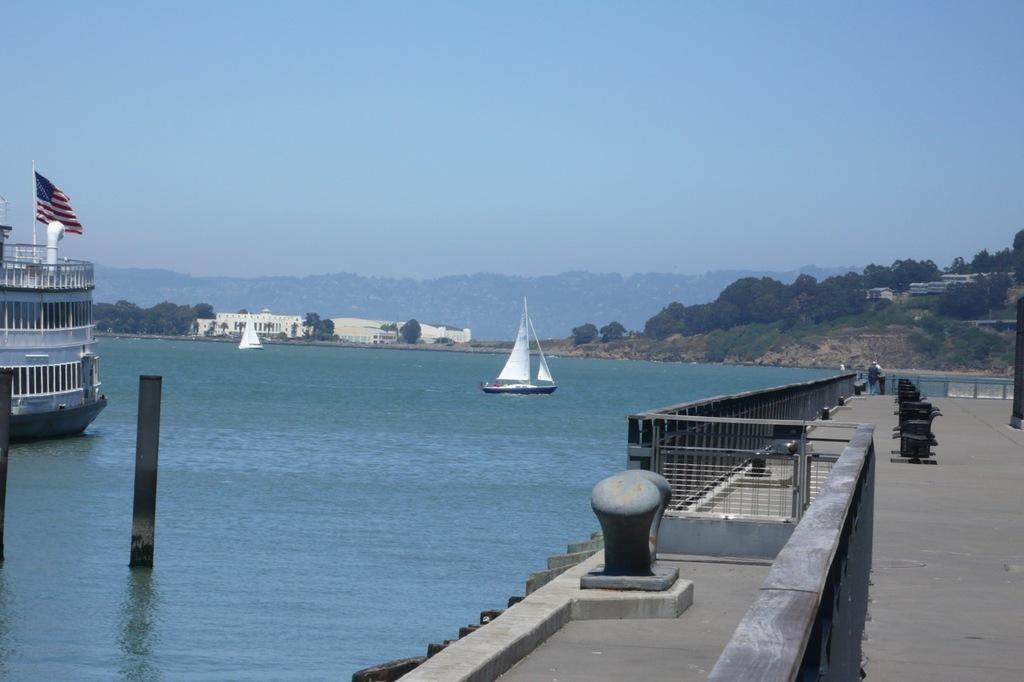How would you summarize this image in a sentence or two? In this image I can see the sea and some boats in the sea. On the left hand side I can see some poles. In the center of the image I can see some buildings, behind the buildings I can see mountains spreading towards the right hand side. At the top of the image I can see the sky. In the right bottom corner I can see a bay area with some chairs, grills and two people standing. 